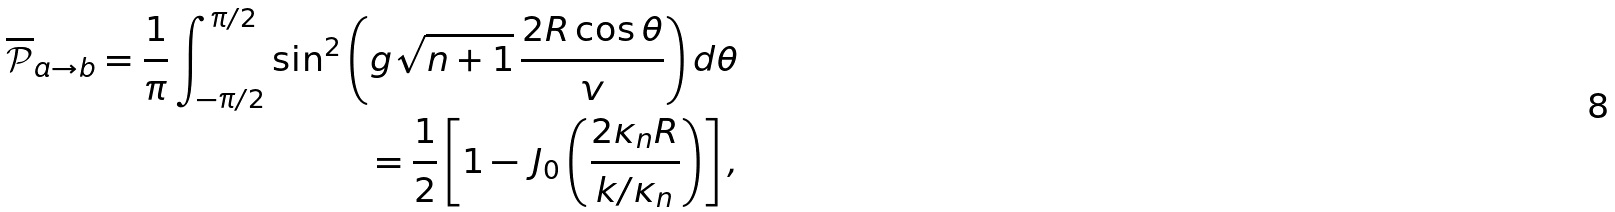Convert formula to latex. <formula><loc_0><loc_0><loc_500><loc_500>\overline { \mathcal { P } } _ { a \to b } = \frac { 1 } { \pi } \int _ { - \pi / 2 } ^ { \pi / 2 } \sin ^ { 2 } \left ( g \sqrt { n + 1 } \, \frac { 2 R \cos \theta } { v } \right ) d \theta \\ = \frac { 1 } { 2 } \left [ 1 - \, J _ { 0 } \left ( \frac { 2 \kappa _ { n } R } { k / \kappa _ { n } } \right ) \right ] ,</formula> 